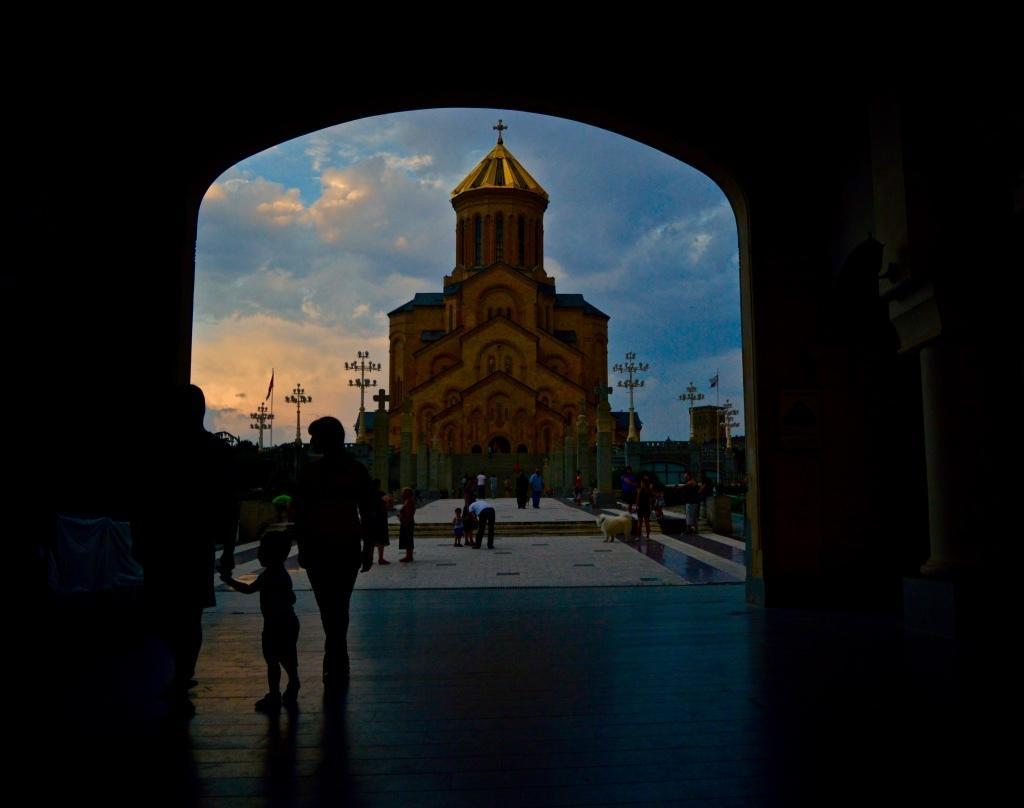Describe this image in one or two sentences. This image is taken during the evening. In the center we can see the church. We can also see some light poles and also people on the floor. There is sky with some clouds. 